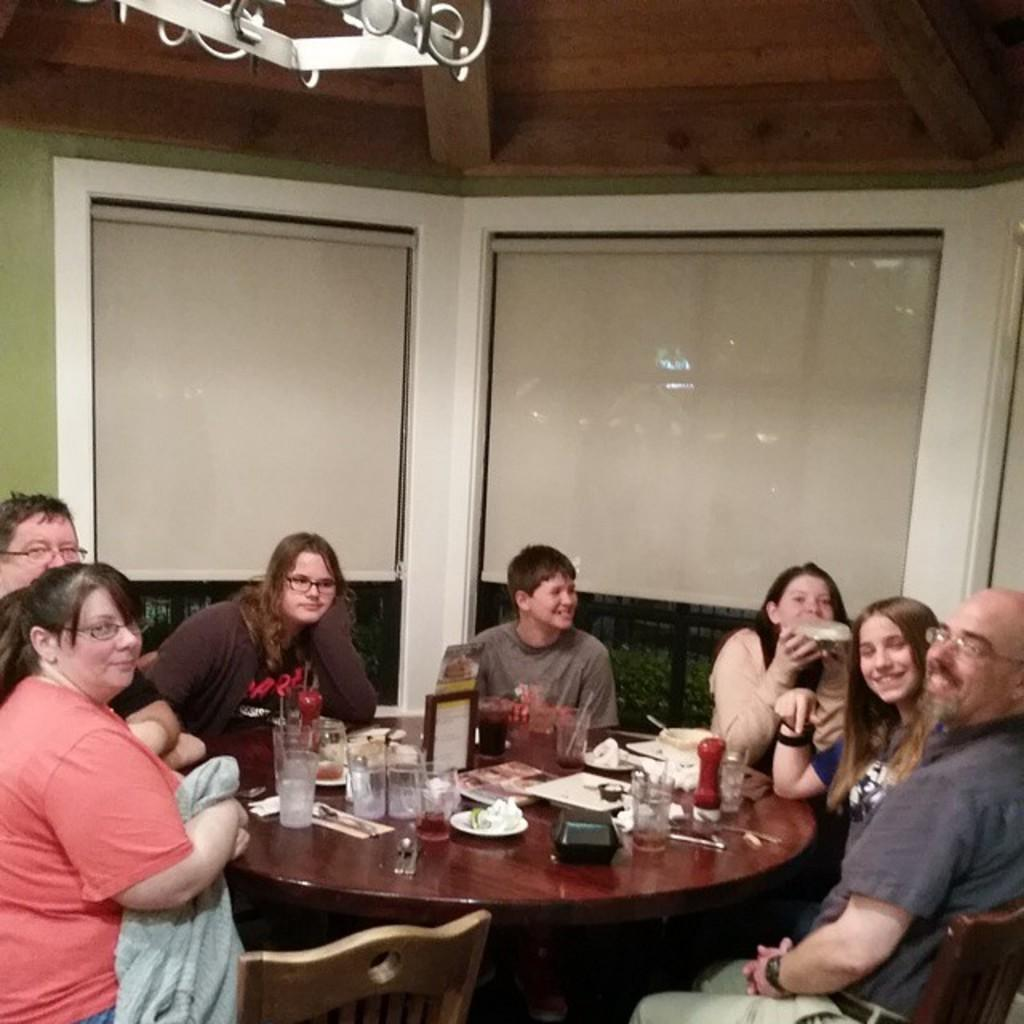What are the people in the image doing? The people in the image are sitting on chairs. Where are the people sitting in relation to the table? The people are in front of a table. What can be seen on the table in the image? There are glasses and other objects on the table. What type of door can be seen in the image? There is no door present in the image. What is the people's dinner choice in the image? The image does not show any dinner or food being consumed by the people. 